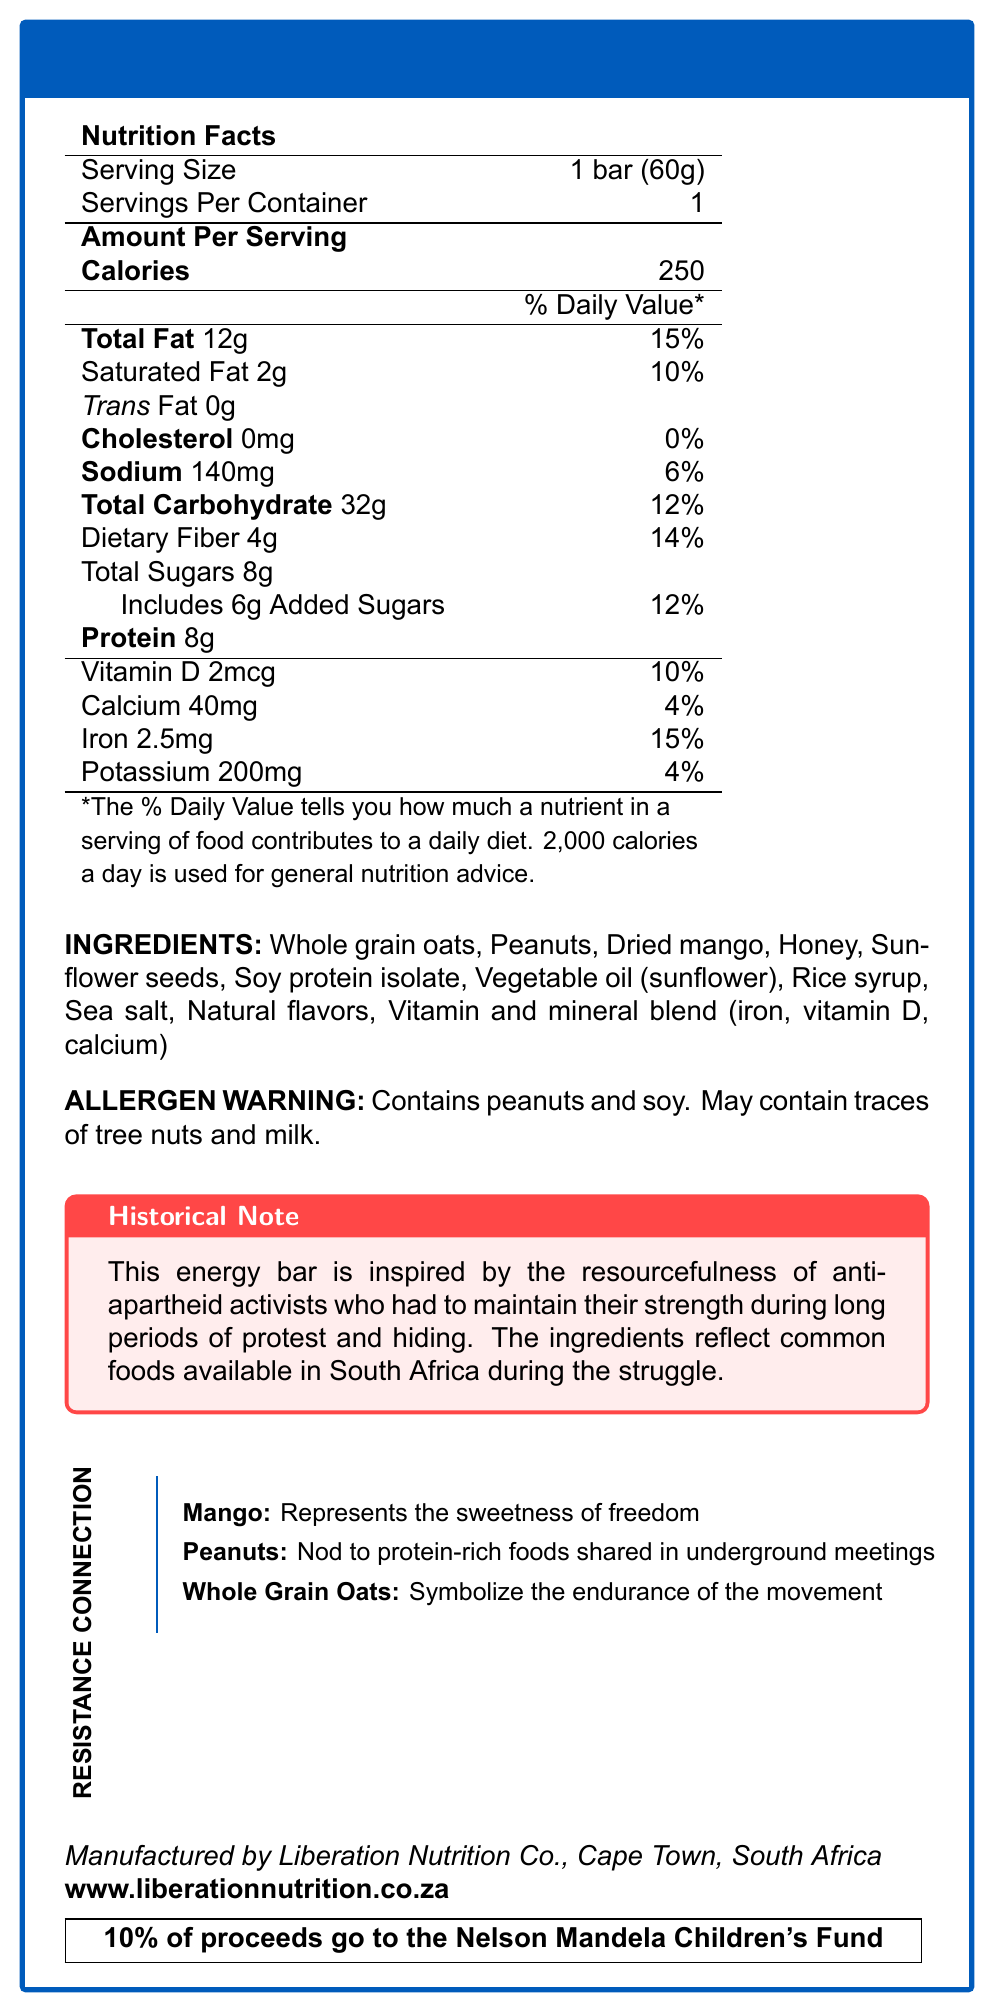what is the serving size of the Freedom Fighter Fuel Bar? The serving size is explicitly mentioned as 1 bar weighing 60 grams.
Answer: 1 bar (60g) how many calories are in one serving of the Freedom Fighter Fuel Bar? The document states that there are 250 calories per serving.
Answer: 250 what is the total fat content per serving? The document indicates that the total fat content per serving is 12 grams.
Answer: 12g how many grams of dietary fiber does the bar contain? The document lists dietary fiber content as 4 grams per serving.
Answer: 4g is the Freedom Fighter Fuel Bar suitable for someone with a nut allergy? The allergen warning states that the bar contains peanuts and may contain traces of tree nuts.
Answer: No what is the significance of mango in the Freedom Fighter Fuel Bar based on the resistance connection section? The document explains that mango symbolizes the sweetness of freedom.
Answer: Represents the sweetness of freedom how many percent of daily value does the iron content in the bar contribute? The iron content contributes 15% to the daily value as per the document.
Answer: 15% which nutrient has the highest percent daily value contribution in the Freedom Fighter Fuel Bar? A. Total Fat B. Saturated Fat C. Dietary Fiber D. Iron The document shows that total fat has the highest daily value contribution at 15%.
Answer: A. Total Fat which company manufactures the Freedom Fighter Fuel Bar? A. Nutrition Freedom Inc. B. Liberation Nutrition Co. C. Health Revolution Co. D. Struggle Snacks Ltd. The manufacturer is listed as Liberation Nutrition Co.
Answer: B. Liberation Nutrition Co. which ingredient is not in the Freedom Fighter Fuel Bar? A. Soy protein isolate B. Dried apple C. Honey D. Sunflower seeds Dried apple is not listed among the ingredients.
Answer: B. Dried apple does the Freedom Fighter Fuel Bar contain any trans fat? The nutritional facts section clearly states that there is 0g trans fat.
Answer: No what percentage of the proceeds go to the Nelson Mandela Children's Fund? The document mentions that 10% of the proceeds are donated to the Nelson Mandela Children's Fund.
Answer: 10% summarize the main idea of the Freedom Fighter Fuel Bar's document. The document presents the nutritional facts, ingredients, allergen information, historical context, symbolic meanings of ingredients, manufacturer details, and the donation initiative related to the Freedom Fighter Fuel Bar.
Answer: The Freedom Fighter Fuel Bar is a commemorative energy bar designed to raise awareness about the nutritional challenges faced during the anti-apartheid struggle. It highlights its nutritional content, ingredients, and historical significance, with proceeds aiding the Nelson Mandela Children's Fund. what is the vitamin D content per serving expressed in micrograms? The document specifies that there are 2mcg of vitamin D per serving.
Answer: 2mcg what challenges are mentioned concerning the nutritional situation during the apartheid era? The document lists these nutritional challenges faced during the apartheid era.
Answer: Limited access to fresh produce, malnutrition among children, lack of dietary diversity, food insecurity what are the natural flavors in the ingredient list? The document mentions natural flavors but does not specify what they are.
Answer: Not enough information how much sodium is in one bar of the Freedom Fighter Fuel Bar? The sodium content per serving is listed as 140mg in the document.
Answer: 140mg 